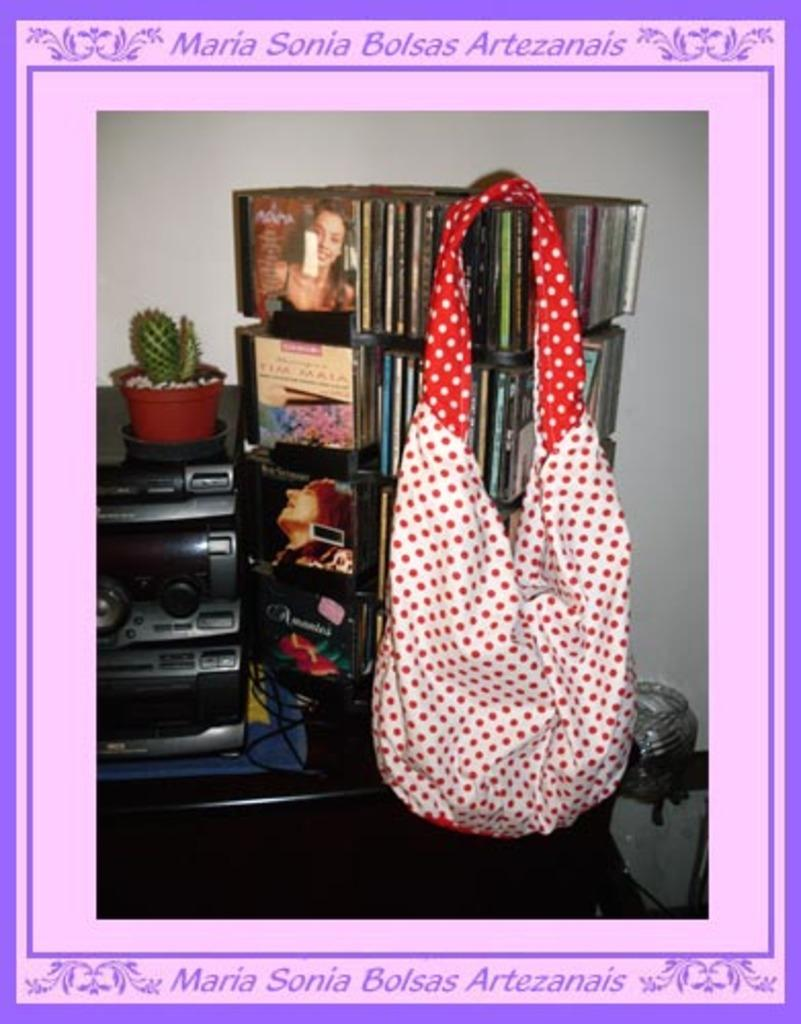What type of objects can be seen in the image? There are books, a radio, a plant, and a bag in the image. Can you describe the plant in the image? The plant in the image is a small, potted plant. What might be used for listening to music or news in the image? There is a radio in the image that can be used for listening to music or news. What can be used for carrying items in the image? There is a bag in the image that can be used for carrying items. What type of star is visible in the image? There is no star visible in the image; it only contains books, a radio, a plant, and a bag. 